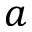<formula> <loc_0><loc_0><loc_500><loc_500>a</formula> 